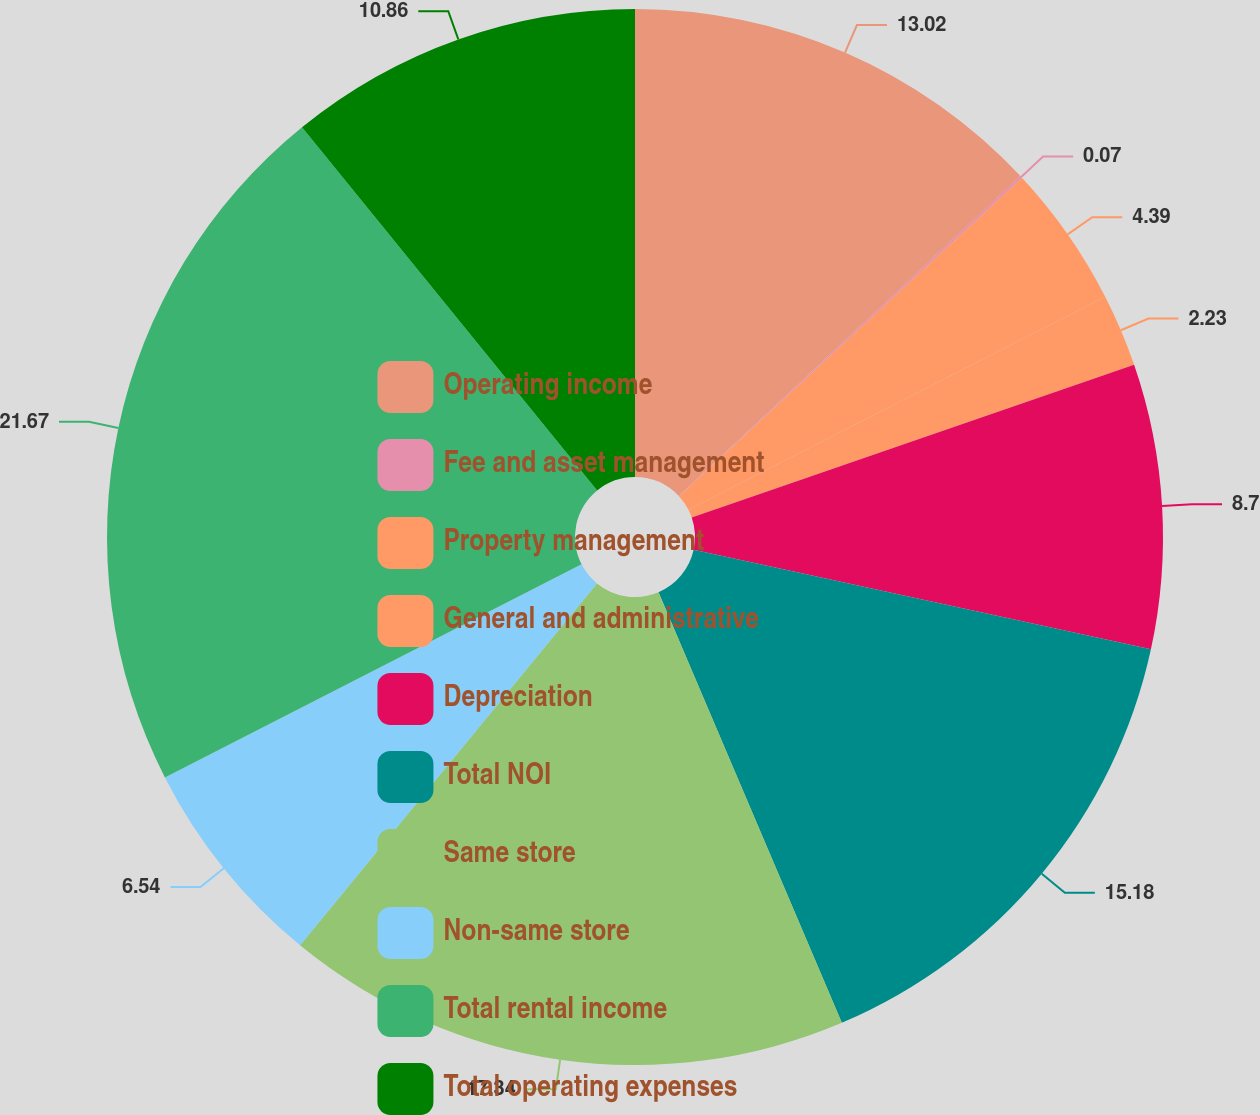Convert chart. <chart><loc_0><loc_0><loc_500><loc_500><pie_chart><fcel>Operating income<fcel>Fee and asset management<fcel>Property management<fcel>General and administrative<fcel>Depreciation<fcel>Total NOI<fcel>Same store<fcel>Non-same store<fcel>Total rental income<fcel>Total operating expenses<nl><fcel>13.02%<fcel>0.07%<fcel>4.39%<fcel>2.23%<fcel>8.7%<fcel>15.18%<fcel>17.34%<fcel>6.54%<fcel>21.66%<fcel>10.86%<nl></chart> 